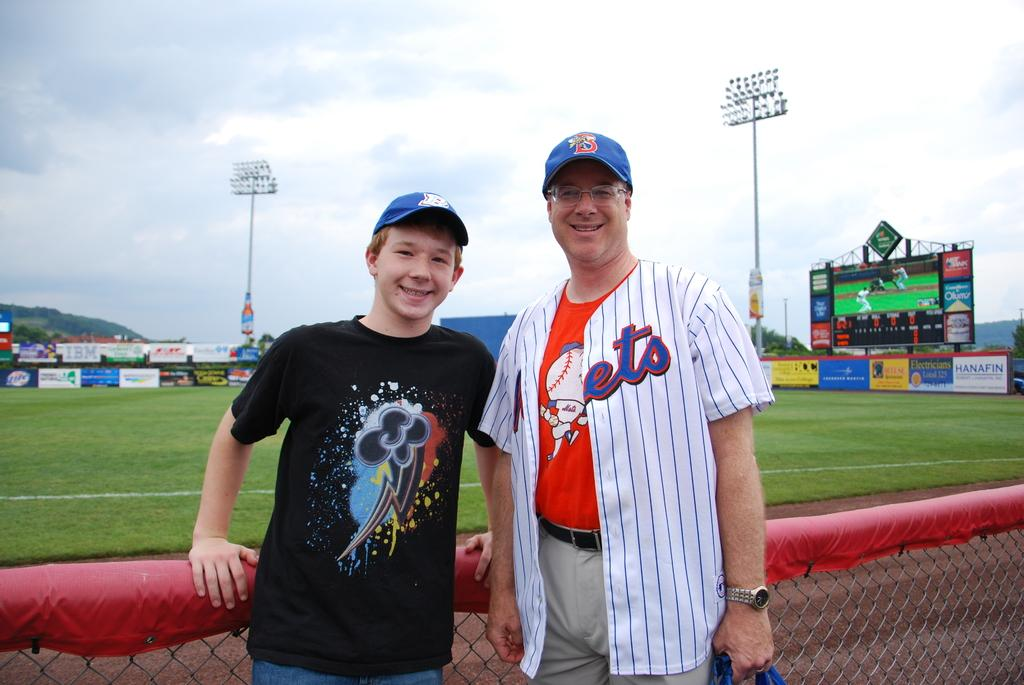<image>
Offer a succinct explanation of the picture presented. A man in a hat with the letter B on it poses next to a fence in a baseball park. 